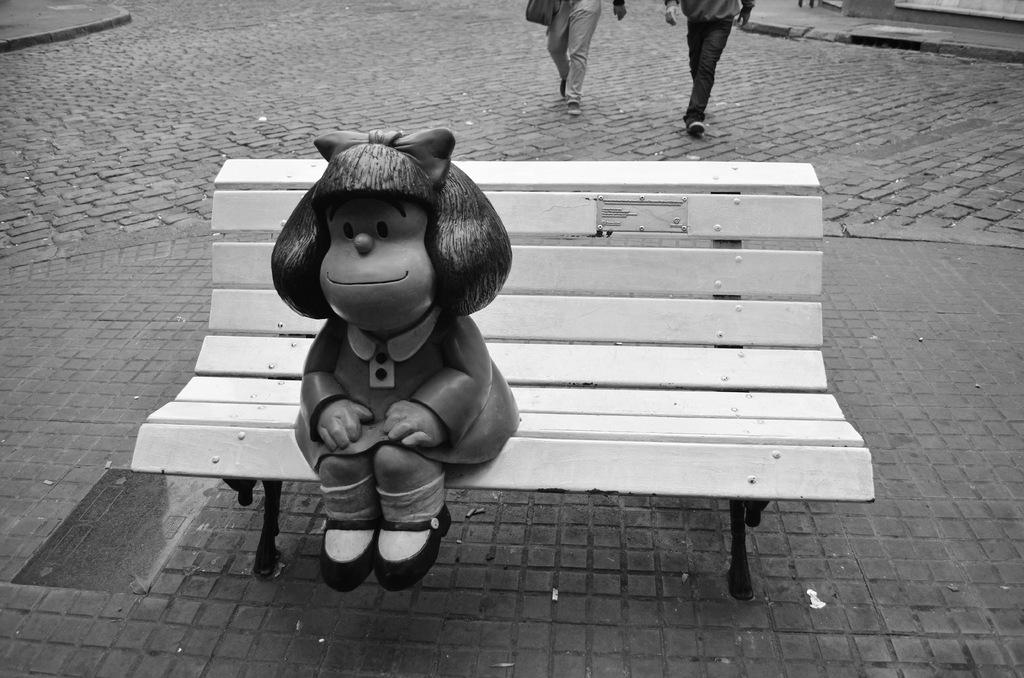What object is placed on the bench in the image? There is a toy on a bench in the image. What are the two people in the image doing? The two people in the image are walking. What type of knowledge can be gained from the fire in the image? There is no fire present in the image, so no such knowledge can be gained. What role does the parent play in the image? There is no mention of a parent in the image, so it is not possible to answer that question. 